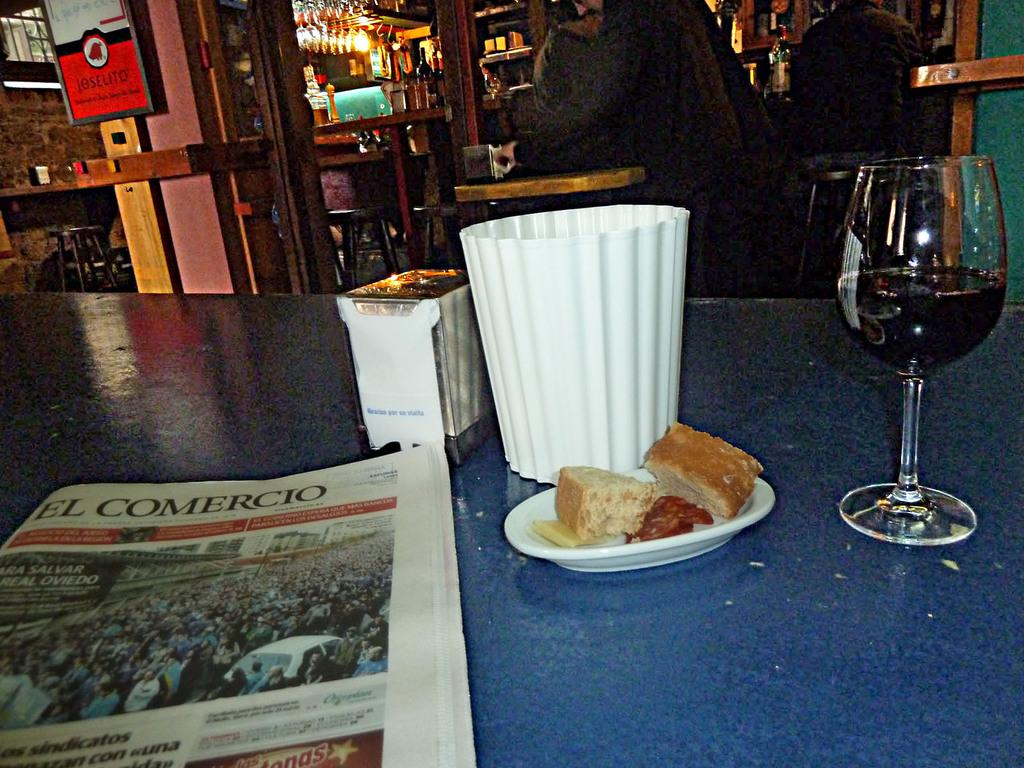<image>
Share a concise interpretation of the image provided. A half full wine glass sits on a table along with a paper from El Comercio 